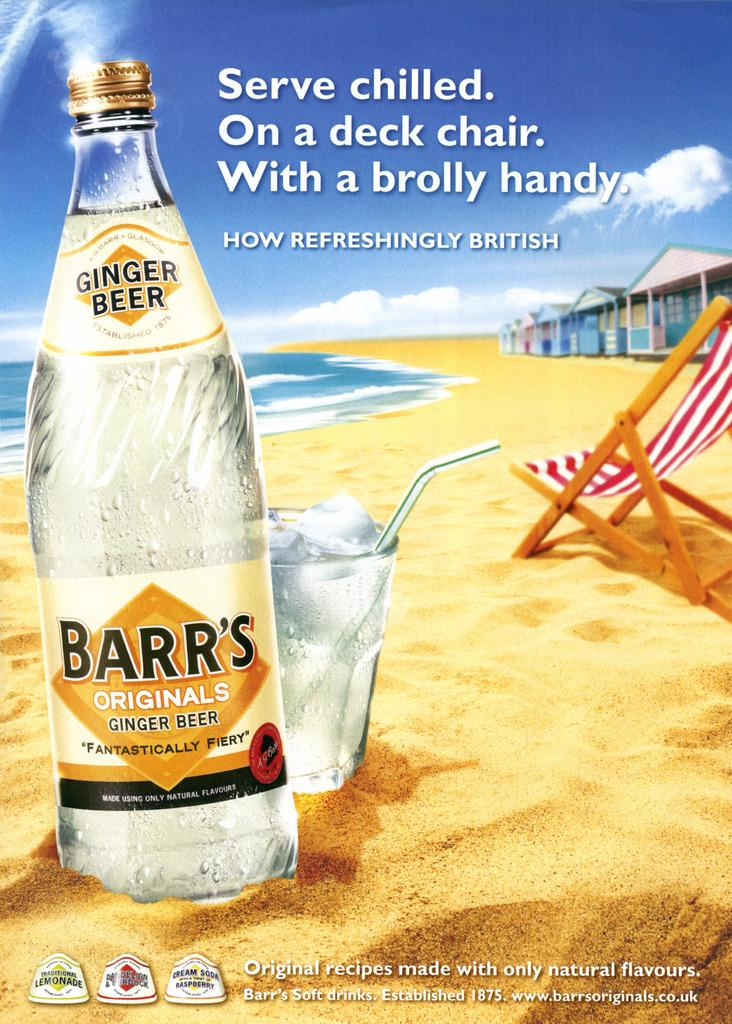<image>
Present a compact description of the photo's key features. An advertisement for Barr's originals ginger beer which is "fantastically fiery" 